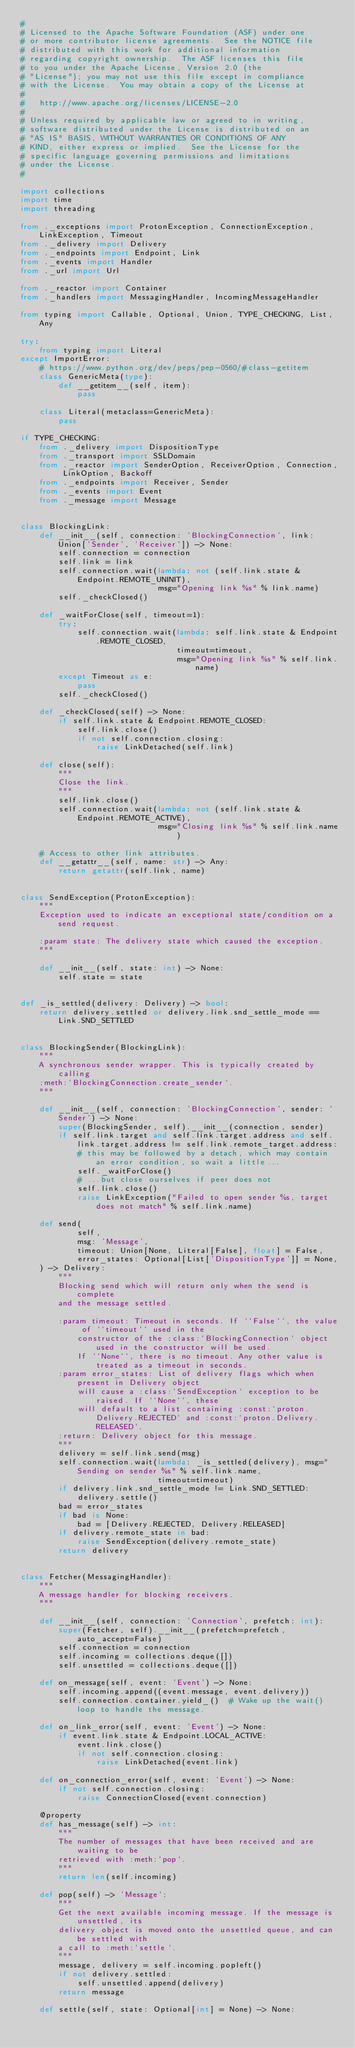Convert code to text. <code><loc_0><loc_0><loc_500><loc_500><_Python_>#
# Licensed to the Apache Software Foundation (ASF) under one
# or more contributor license agreements.  See the NOTICE file
# distributed with this work for additional information
# regarding copyright ownership.  The ASF licenses this file
# to you under the Apache License, Version 2.0 (the
# "License"); you may not use this file except in compliance
# with the License.  You may obtain a copy of the License at
#
#   http://www.apache.org/licenses/LICENSE-2.0
#
# Unless required by applicable law or agreed to in writing,
# software distributed under the License is distributed on an
# "AS IS" BASIS, WITHOUT WARRANTIES OR CONDITIONS OF ANY
# KIND, either express or implied.  See the License for the
# specific language governing permissions and limitations
# under the License.
#

import collections
import time
import threading

from ._exceptions import ProtonException, ConnectionException, LinkException, Timeout
from ._delivery import Delivery
from ._endpoints import Endpoint, Link
from ._events import Handler
from ._url import Url

from ._reactor import Container
from ._handlers import MessagingHandler, IncomingMessageHandler

from typing import Callable, Optional, Union, TYPE_CHECKING, List, Any

try:
    from typing import Literal
except ImportError:
    # https://www.python.org/dev/peps/pep-0560/#class-getitem
    class GenericMeta(type):
        def __getitem__(self, item):
            pass

    class Literal(metaclass=GenericMeta):
        pass

if TYPE_CHECKING:
    from ._delivery import DispositionType
    from ._transport import SSLDomain
    from ._reactor import SenderOption, ReceiverOption, Connection, LinkOption, Backoff
    from ._endpoints import Receiver, Sender
    from ._events import Event
    from ._message import Message


class BlockingLink:
    def __init__(self, connection: 'BlockingConnection', link: Union['Sender', 'Receiver']) -> None:
        self.connection = connection
        self.link = link
        self.connection.wait(lambda: not (self.link.state & Endpoint.REMOTE_UNINIT),
                             msg="Opening link %s" % link.name)
        self._checkClosed()

    def _waitForClose(self, timeout=1):
        try:
            self.connection.wait(lambda: self.link.state & Endpoint.REMOTE_CLOSED,
                                 timeout=timeout,
                                 msg="Opening link %s" % self.link.name)
        except Timeout as e:
            pass
        self._checkClosed()

    def _checkClosed(self) -> None:
        if self.link.state & Endpoint.REMOTE_CLOSED:
            self.link.close()
            if not self.connection.closing:
                raise LinkDetached(self.link)

    def close(self):
        """
        Close the link.
        """
        self.link.close()
        self.connection.wait(lambda: not (self.link.state & Endpoint.REMOTE_ACTIVE),
                             msg="Closing link %s" % self.link.name)

    # Access to other link attributes.
    def __getattr__(self, name: str) -> Any:
        return getattr(self.link, name)


class SendException(ProtonException):
    """
    Exception used to indicate an exceptional state/condition on a send request.

    :param state: The delivery state which caused the exception.
    """

    def __init__(self, state: int) -> None:
        self.state = state


def _is_settled(delivery: Delivery) -> bool:
    return delivery.settled or delivery.link.snd_settle_mode == Link.SND_SETTLED


class BlockingSender(BlockingLink):
    """
    A synchronous sender wrapper. This is typically created by calling
    :meth:`BlockingConnection.create_sender`.
    """

    def __init__(self, connection: 'BlockingConnection', sender: 'Sender') -> None:
        super(BlockingSender, self).__init__(connection, sender)
        if self.link.target and self.link.target.address and self.link.target.address != self.link.remote_target.address:
            # this may be followed by a detach, which may contain an error condition, so wait a little...
            self._waitForClose()
            # ...but close ourselves if peer does not
            self.link.close()
            raise LinkException("Failed to open sender %s, target does not match" % self.link.name)

    def send(
            self,
            msg: 'Message',
            timeout: Union[None, Literal[False], float] = False,
            error_states: Optional[List['DispositionType']] = None,
    ) -> Delivery:
        """
        Blocking send which will return only when the send is complete
        and the message settled.

        :param timeout: Timeout in seconds. If ``False``, the value of ``timeout`` used in the
            constructor of the :class:`BlockingConnection` object used in the constructor will be used.
            If ``None``, there is no timeout. Any other value is treated as a timeout in seconds.
        :param error_states: List of delivery flags which when present in Delivery object
            will cause a :class:`SendException` exception to be raised. If ``None``, these
            will default to a list containing :const:`proton.Delivery.REJECTED` and :const:`proton.Delivery.RELEASED`.
        :return: Delivery object for this message.
        """
        delivery = self.link.send(msg)
        self.connection.wait(lambda: _is_settled(delivery), msg="Sending on sender %s" % self.link.name,
                             timeout=timeout)
        if delivery.link.snd_settle_mode != Link.SND_SETTLED:
            delivery.settle()
        bad = error_states
        if bad is None:
            bad = [Delivery.REJECTED, Delivery.RELEASED]
        if delivery.remote_state in bad:
            raise SendException(delivery.remote_state)
        return delivery


class Fetcher(MessagingHandler):
    """
    A message handler for blocking receivers.
    """

    def __init__(self, connection: 'Connection', prefetch: int):
        super(Fetcher, self).__init__(prefetch=prefetch, auto_accept=False)
        self.connection = connection
        self.incoming = collections.deque([])
        self.unsettled = collections.deque([])

    def on_message(self, event: 'Event') -> None:
        self.incoming.append((event.message, event.delivery))
        self.connection.container.yield_()  # Wake up the wait() loop to handle the message.

    def on_link_error(self, event: 'Event') -> None:
        if event.link.state & Endpoint.LOCAL_ACTIVE:
            event.link.close()
            if not self.connection.closing:
                raise LinkDetached(event.link)

    def on_connection_error(self, event: 'Event') -> None:
        if not self.connection.closing:
            raise ConnectionClosed(event.connection)

    @property
    def has_message(self) -> int:
        """
        The number of messages that have been received and are waiting to be
        retrieved with :meth:`pop`.
        """
        return len(self.incoming)

    def pop(self) -> 'Message':
        """
        Get the next available incoming message. If the message is unsettled, its
        delivery object is moved onto the unsettled queue, and can be settled with
        a call to :meth:`settle`.
        """
        message, delivery = self.incoming.popleft()
        if not delivery.settled:
            self.unsettled.append(delivery)
        return message

    def settle(self, state: Optional[int] = None) -> None:</code> 